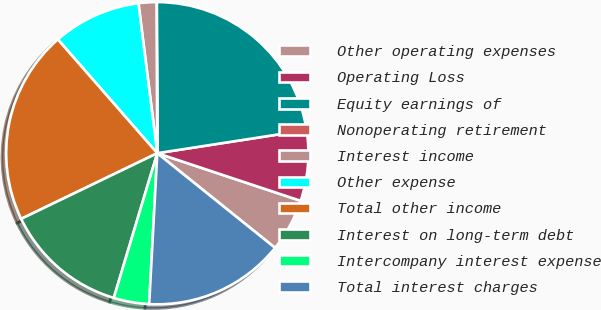Convert chart. <chart><loc_0><loc_0><loc_500><loc_500><pie_chart><fcel>Other operating expenses<fcel>Operating Loss<fcel>Equity earnings of<fcel>Nonoperating retirement<fcel>Interest income<fcel>Other expense<fcel>Total other income<fcel>Interest on long-term debt<fcel>Intercompany interest expense<fcel>Total interest charges<nl><fcel>5.67%<fcel>7.55%<fcel>22.6%<fcel>0.03%<fcel>1.91%<fcel>9.44%<fcel>20.72%<fcel>13.2%<fcel>3.79%<fcel>15.08%<nl></chart> 